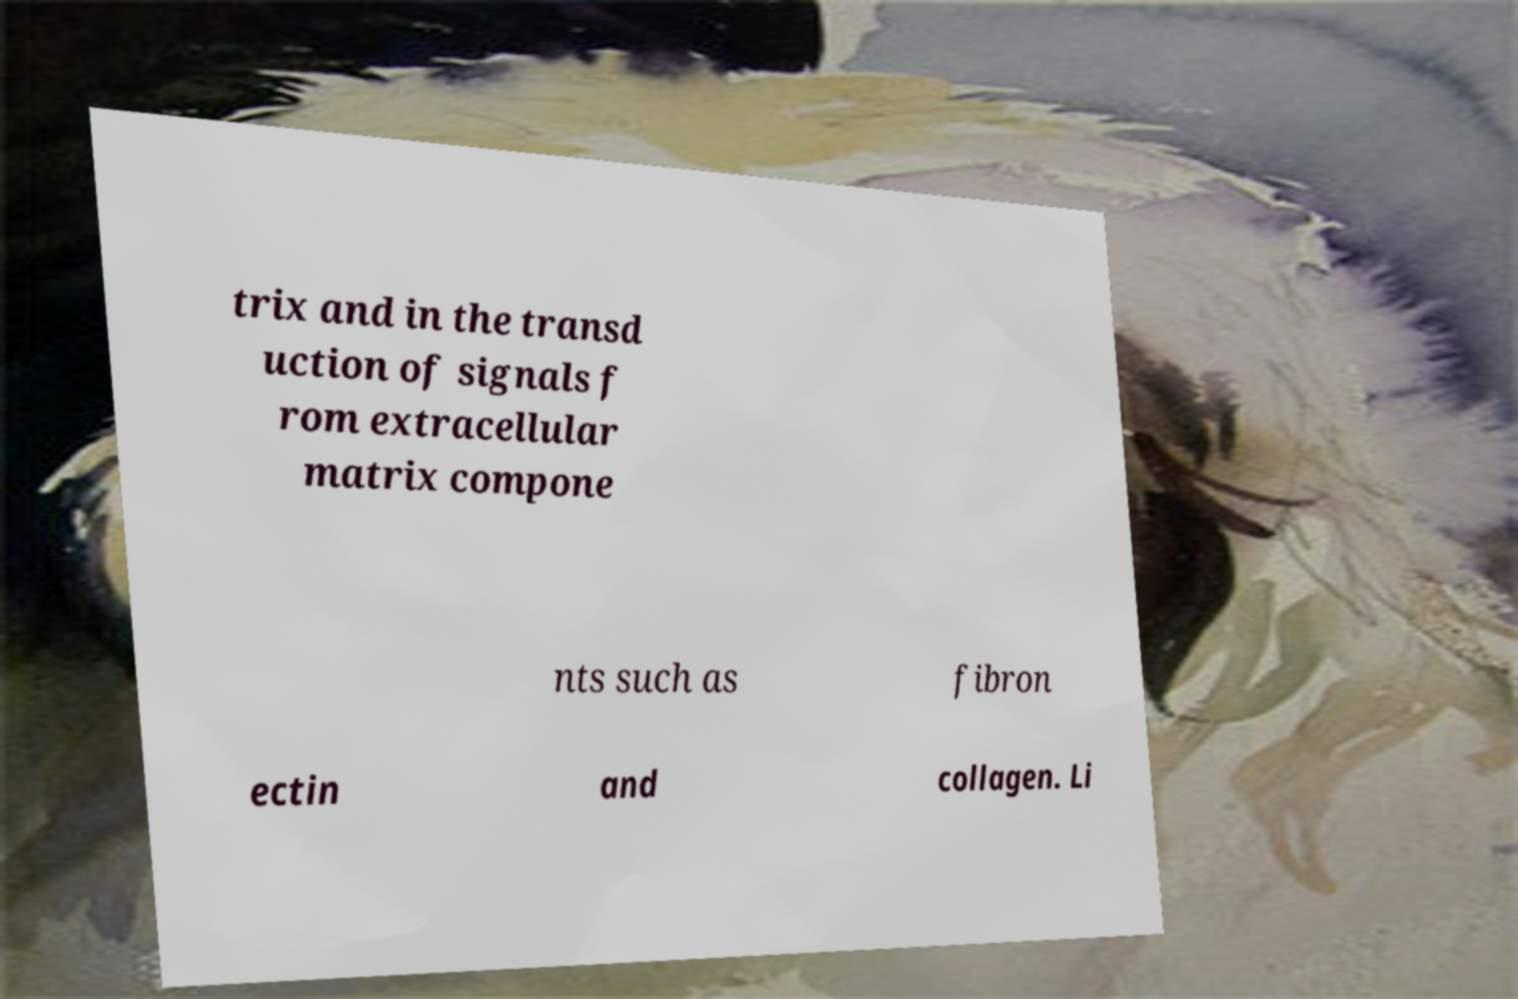I need the written content from this picture converted into text. Can you do that? trix and in the transd uction of signals f rom extracellular matrix compone nts such as fibron ectin and collagen. Li 